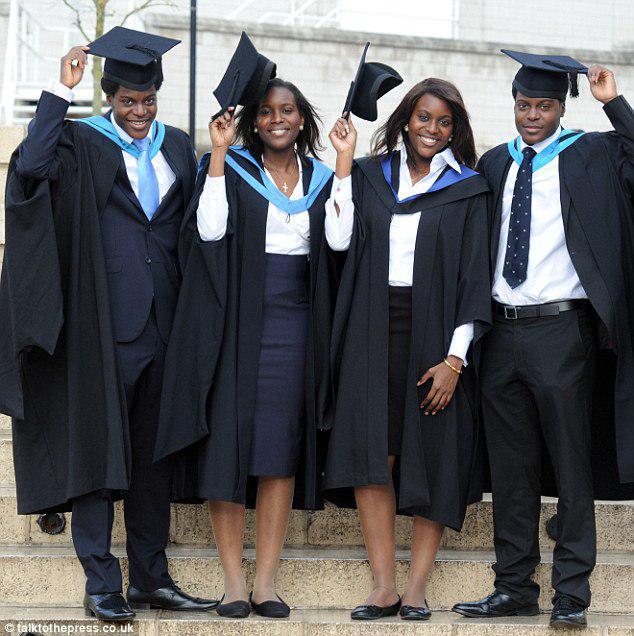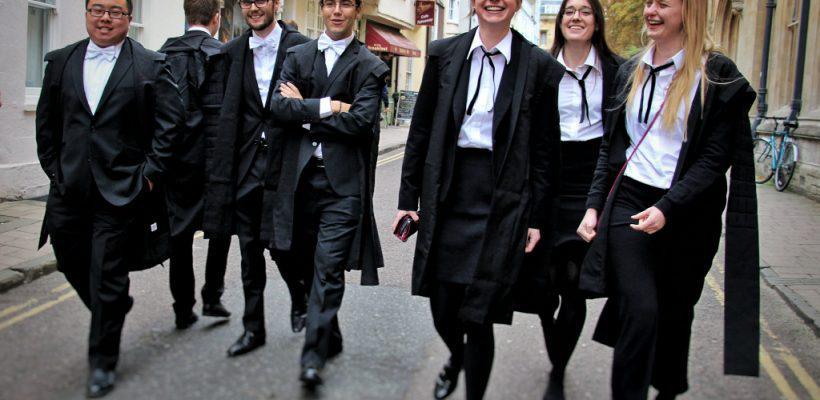The first image is the image on the left, the second image is the image on the right. Examine the images to the left and right. Is the description "In one image at least two male graduates are wearing white bow ties and at least one female graduate is wearing an untied black string tie and black hosiery." accurate? Answer yes or no. Yes. The first image is the image on the left, the second image is the image on the right. For the images displayed, is the sentence "The left image contains no more than four graduation students." factually correct? Answer yes or no. Yes. 